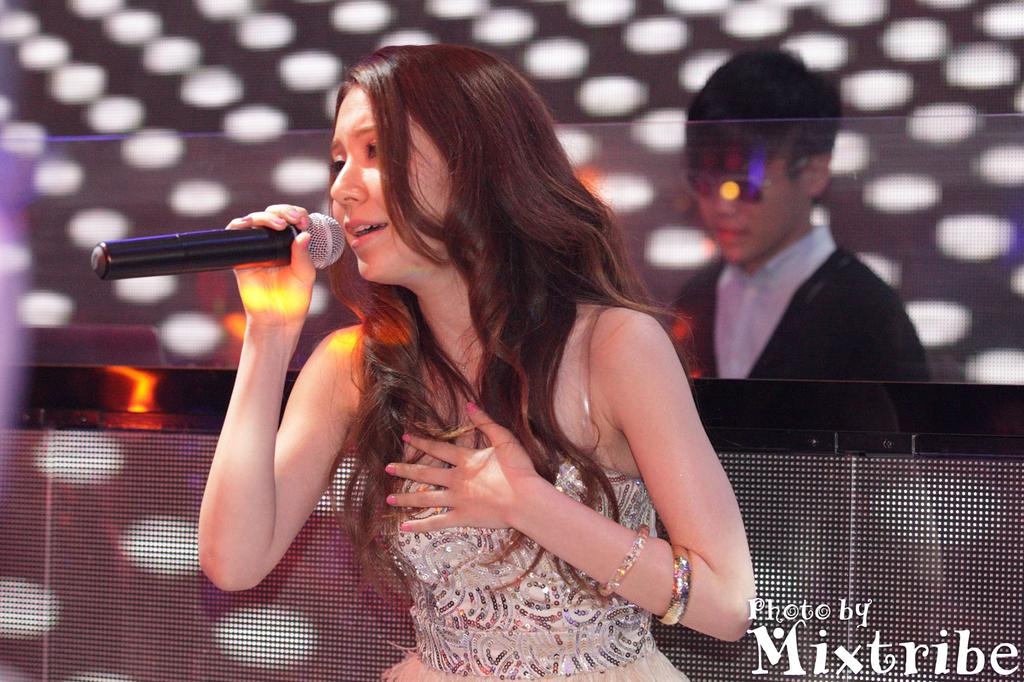Who is the main subject in the image? There is a woman in the image. What is the woman doing in the image? The woman is sitting in the middle and holding a black microphone. Can you describe the boy in the image? The boy is in the background of the image and is standing. What type of butter is being used in the image? There is no butter present in the image. What kind of voyage is the woman taking in the image? The image does not depict a voyage; it shows a woman sitting with a microphone and a boy standing in the background. 